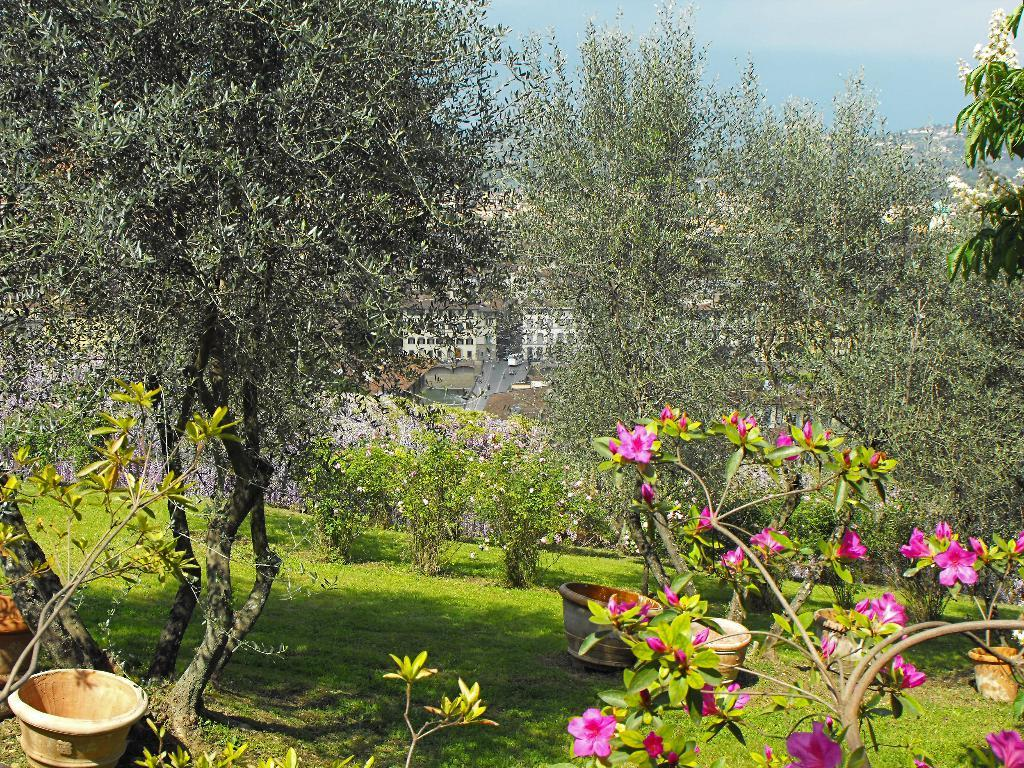What type of vegetation is present in the image? There are trees with branches and leaves in the image. What objects are used for planting in the image? There are flower pots in the image. What type of plant is visible in the image? There is a plant with flowers in the image. What type of ground cover is present in the image? There is grass in the image. What can be seen in the distance in the image? There are buildings visible in the background of the image. What role does the actor play in the image? There is no actor present in the image; it features natural elements such as trees, flower pots, and plants. What type of farming equipment is visible in the image? There is no farming equipment, such as a plough, present in the image. 